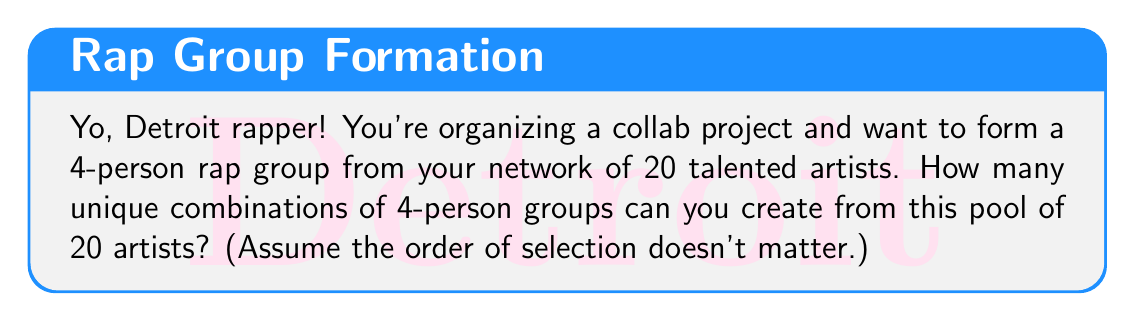Give your solution to this math problem. Let's break this down step by step:

1) This is a combination problem. We're selecting 4 people from a group of 20, where the order doesn't matter.

2) The formula for combinations is:

   $$C(n,r) = \frac{n!}{r!(n-r)!}$$

   Where $n$ is the total number of items to choose from, and $r$ is the number of items being chosen.

3) In this case, $n = 20$ (total artists) and $r = 4$ (size of each group).

4) Plugging these values into our formula:

   $$C(20,4) = \frac{20!}{4!(20-4)!} = \frac{20!}{4!16!}$$

5) Expanding this:
   
   $$\frac{20 \cdot 19 \cdot 18 \cdot 17 \cdot 16!}{(4 \cdot 3 \cdot 2 \cdot 1) \cdot 16!}$$

6) The 16! cancels out in the numerator and denominator:

   $$\frac{20 \cdot 19 \cdot 18 \cdot 17}{4 \cdot 3 \cdot 2 \cdot 1}$$

7) Multiplying the numerator and denominator:

   $$\frac{116,280}{24} = 4,845$$

Therefore, you can form 4,845 unique 4-person rap groups from your pool of 20 artists.
Answer: 4,845 unique combinations 